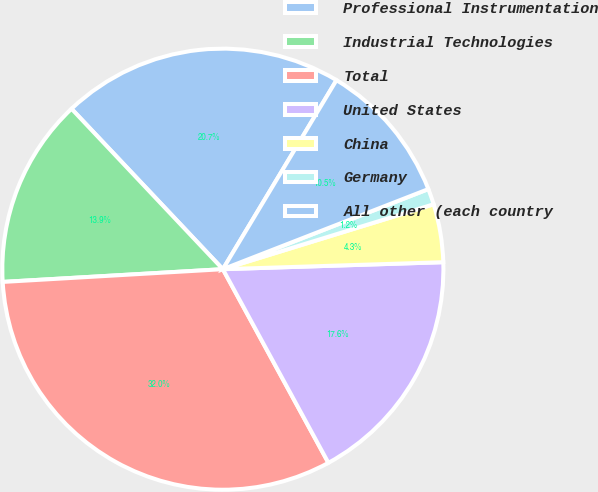Convert chart to OTSL. <chart><loc_0><loc_0><loc_500><loc_500><pie_chart><fcel>Professional Instrumentation<fcel>Industrial Technologies<fcel>Total<fcel>United States<fcel>China<fcel>Germany<fcel>All other (each country<nl><fcel>20.65%<fcel>13.88%<fcel>32.02%<fcel>17.56%<fcel>4.25%<fcel>1.16%<fcel>10.47%<nl></chart> 